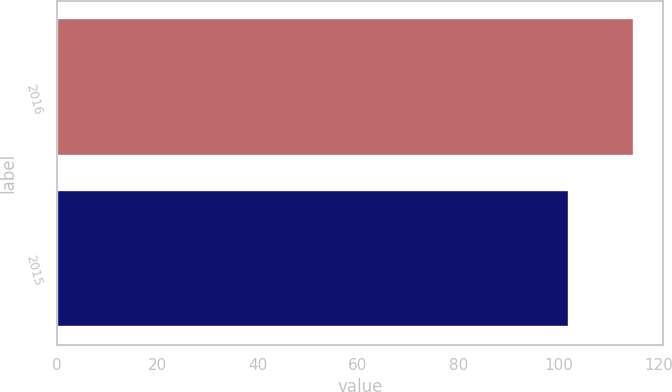<chart> <loc_0><loc_0><loc_500><loc_500><bar_chart><fcel>2016<fcel>2015<nl><fcel>115<fcel>102<nl></chart> 